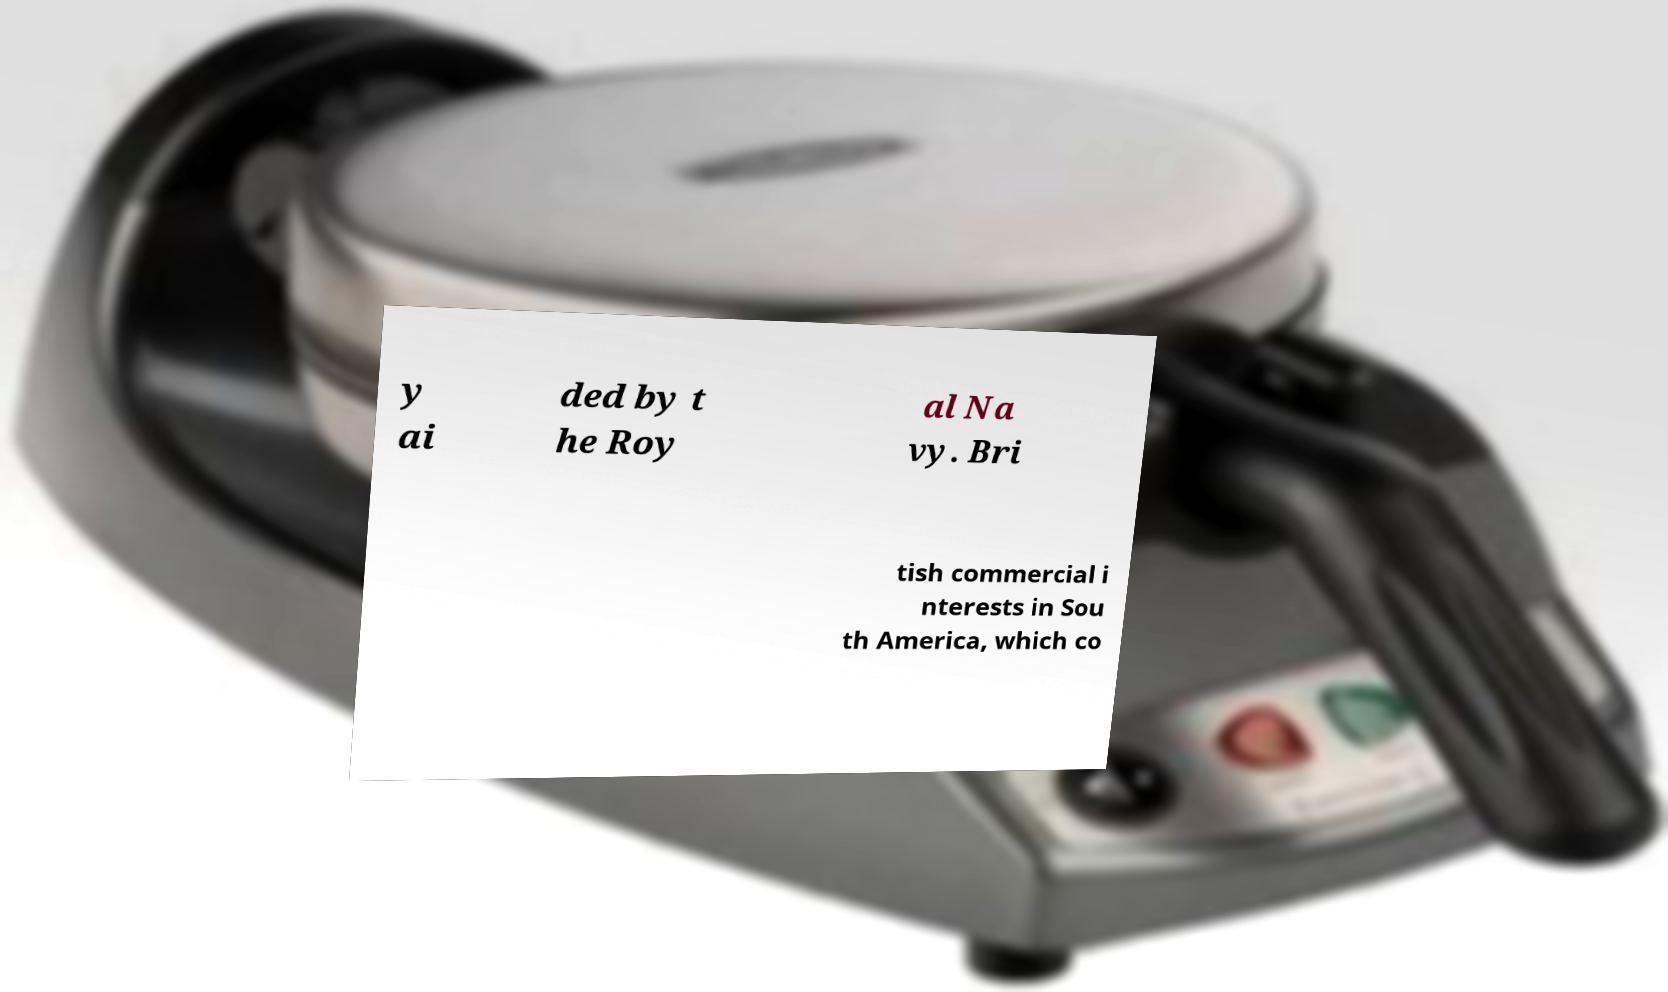Could you assist in decoding the text presented in this image and type it out clearly? y ai ded by t he Roy al Na vy. Bri tish commercial i nterests in Sou th America, which co 